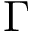<formula> <loc_0><loc_0><loc_500><loc_500>\Gamma</formula> 